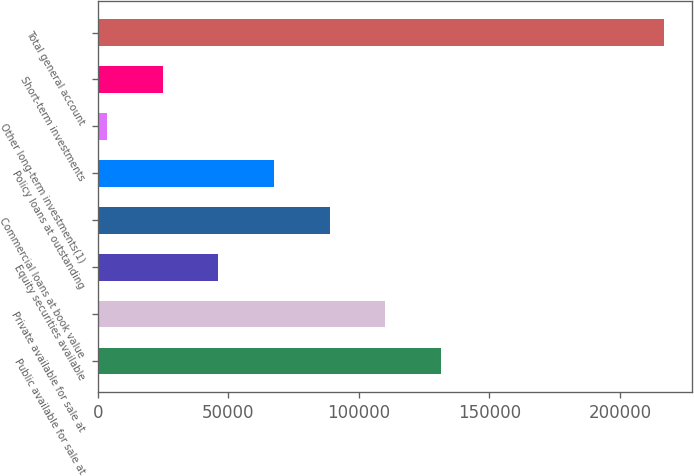Convert chart to OTSL. <chart><loc_0><loc_0><loc_500><loc_500><bar_chart><fcel>Public available for sale at<fcel>Private available for sale at<fcel>Equity securities available<fcel>Commercial loans at book value<fcel>Policy loans at outstanding<fcel>Other long-term investments(1)<fcel>Short-term investments<fcel>Total general account<nl><fcel>131501<fcel>110166<fcel>46161<fcel>88831<fcel>67496<fcel>3491<fcel>24826<fcel>216841<nl></chart> 